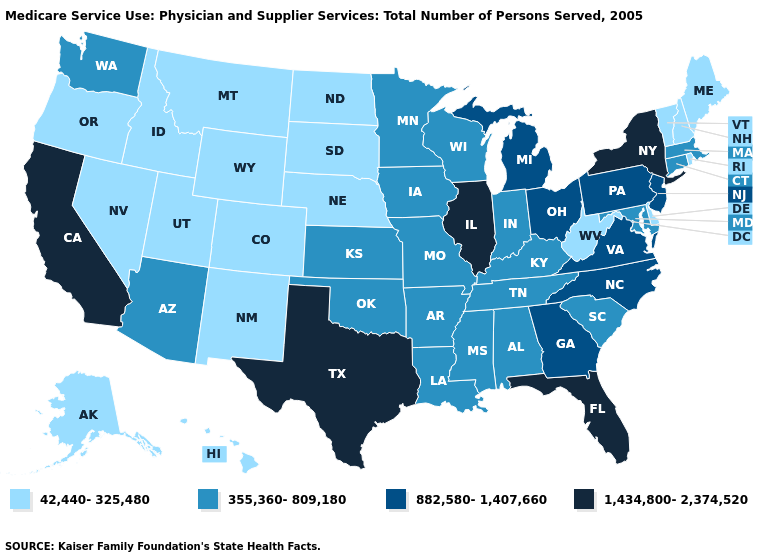Does Iowa have a higher value than California?
Concise answer only. No. What is the value of Rhode Island?
Write a very short answer. 42,440-325,480. Does the first symbol in the legend represent the smallest category?
Concise answer only. Yes. Does Missouri have the highest value in the MidWest?
Write a very short answer. No. What is the value of North Carolina?
Quick response, please. 882,580-1,407,660. What is the value of Kentucky?
Quick response, please. 355,360-809,180. What is the value of Arizona?
Short answer required. 355,360-809,180. What is the value of Vermont?
Quick response, please. 42,440-325,480. Does Texas have the highest value in the USA?
Concise answer only. Yes. Which states have the lowest value in the Northeast?
Give a very brief answer. Maine, New Hampshire, Rhode Island, Vermont. Which states have the lowest value in the South?
Concise answer only. Delaware, West Virginia. What is the lowest value in states that border Michigan?
Quick response, please. 355,360-809,180. Among the states that border Illinois , which have the lowest value?
Short answer required. Indiana, Iowa, Kentucky, Missouri, Wisconsin. Name the states that have a value in the range 882,580-1,407,660?
Keep it brief. Georgia, Michigan, New Jersey, North Carolina, Ohio, Pennsylvania, Virginia. 